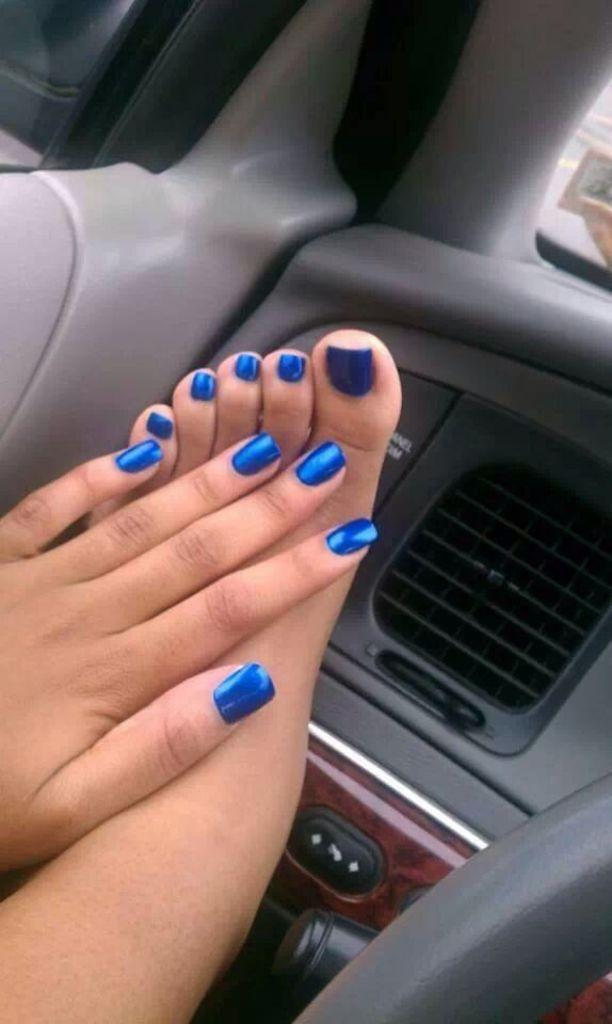What body part of a person can be seen in the image? A person's hand and leg are visible in the image. What object is present in the image that is typically used for controlling a vehicle? There is a steering wheel in the image. What type of view does the image provide? The image provides an inside view of a vehicle. What type of square feast is being prepared on the salt in the image? There is no square feast or salt present in the image; it provides an inside view of a vehicle with a person's hand and leg visible, along with a steering wheel. 